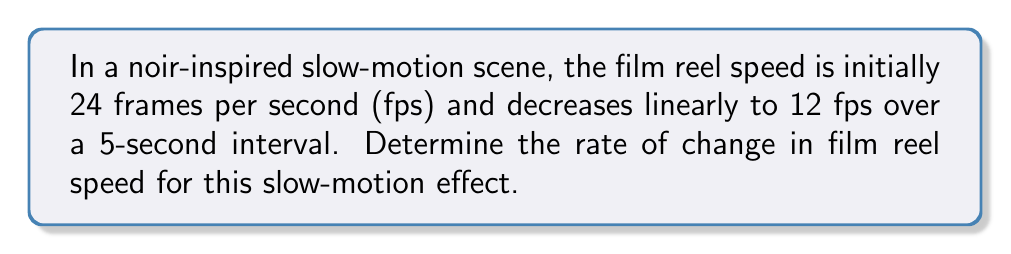Provide a solution to this math problem. To solve this problem, we'll use the concept of rate of change, which is essentially the slope of a linear function. Let's approach this step-by-step:

1) First, let's identify our variables:
   - Initial speed: 24 fps
   - Final speed: 12 fps
   - Time interval: 5 seconds

2) The rate of change formula is:
   $$\text{Rate of change} = \frac{\text{Change in y}}{\text{Change in x}} = \frac{\Delta y}{\Delta x}$$

3) In this case:
   - $\Delta y$ is the change in speed (final - initial)
   - $\Delta x$ is the change in time

4) Let's calculate:
   $$\text{Rate of change} = \frac{12 \text{ fps} - 24 \text{ fps}}{5 \text{ seconds} - 0 \text{ seconds}}$$

5) Simplify:
   $$\text{Rate of change} = \frac{-12 \text{ fps}}{5 \text{ seconds}}$$

6) Divide:
   $$\text{Rate of change} = -2.4 \text{ fps/second}$$

The negative sign indicates that the speed is decreasing over time.
Answer: $-2.4 \text{ fps/second}$ 